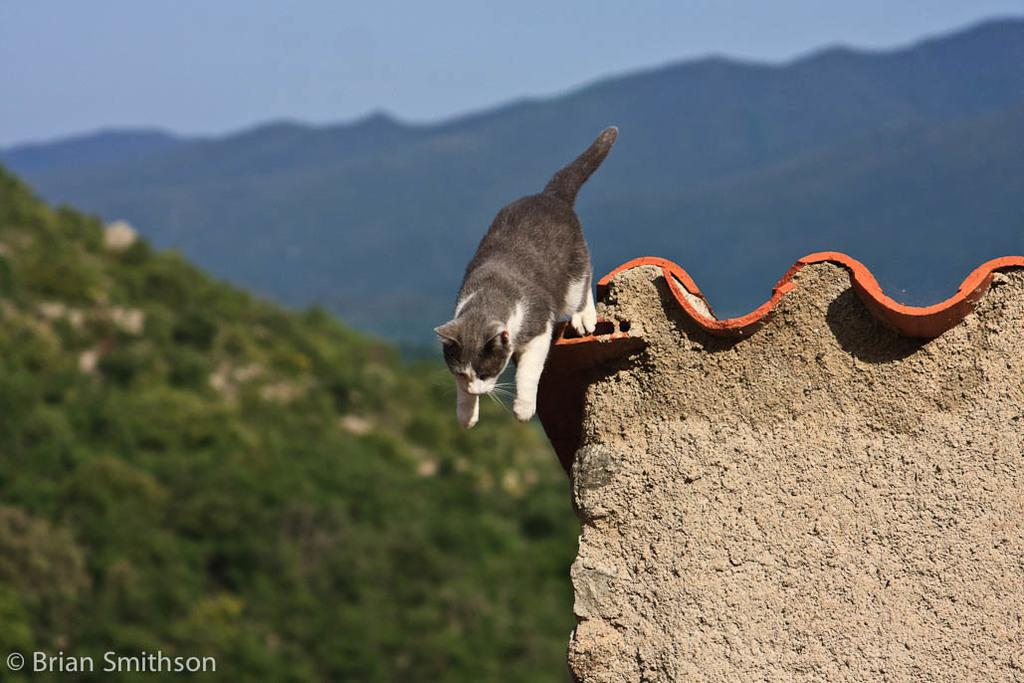What type of animal can be seen in the image? There is a cat in the image. What is the primary feature in the foreground of the image? There is a wall in the image. How would you describe the background of the image? The background of the image has a blurred view, with trees, mountains, and the sky visible. Can you identify any watermark in the image? Yes, there is a watermark in the left side bottom corner of the image. What type of relation does the cat have with the pot in the image? There is no pot present in the image, so the cat does not have any relation with a pot. 